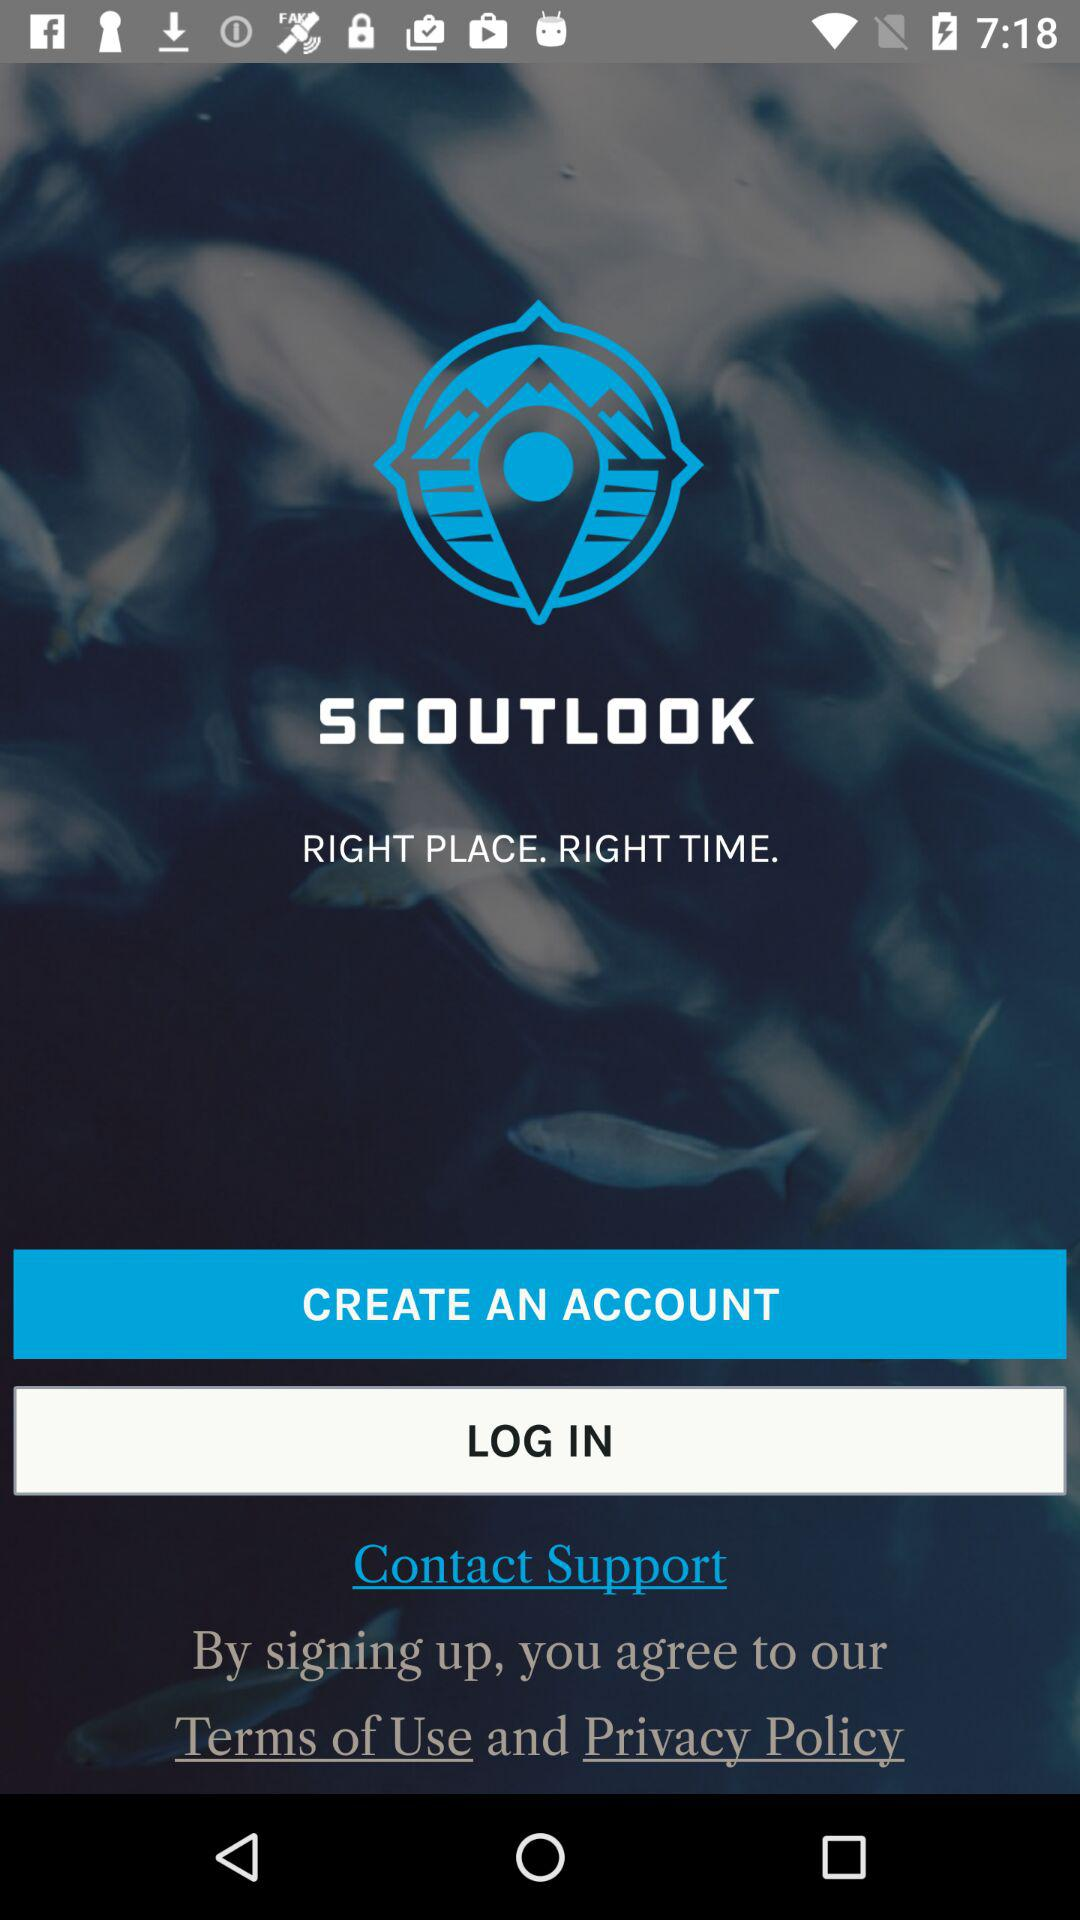What is the tagline of the app? The tagline of the app is "RIGHT PLACE. RIGHT TIME.". 